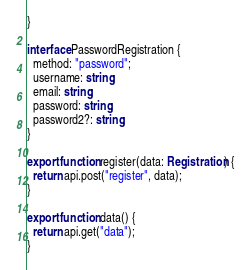Convert code to text. <code><loc_0><loc_0><loc_500><loc_500><_TypeScript_>}

interface PasswordRegistration {
  method: "password";
  username: string;
  email: string;
  password: string;
  password2?: string;
}

export function register(data: Registration) {
  return api.post("register", data);
}

export function data() {
  return api.get("data");
}
</code> 